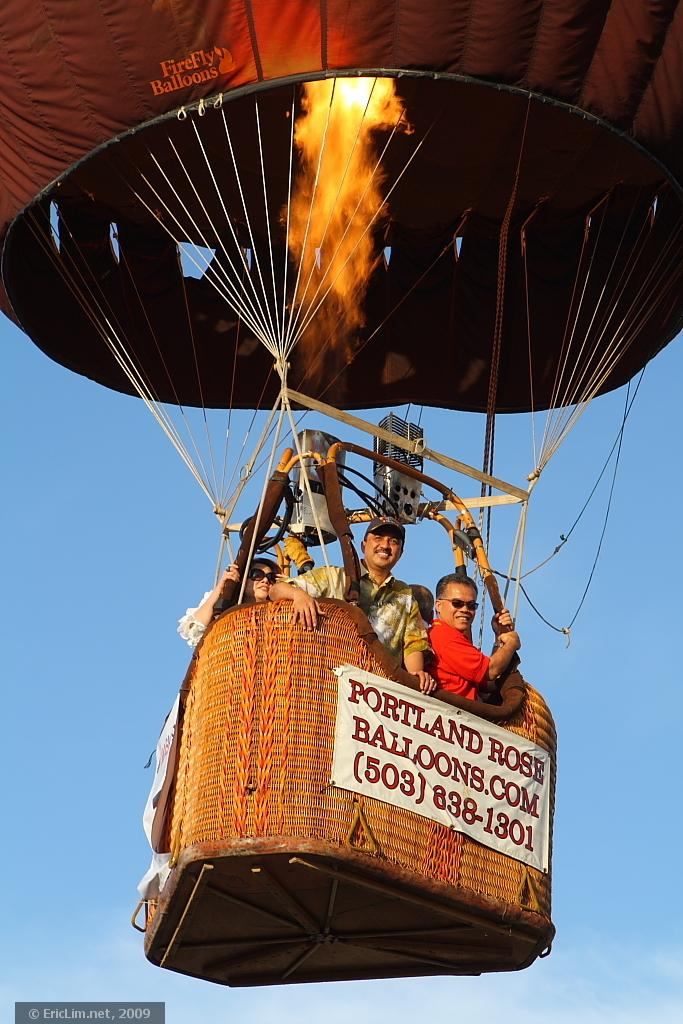<image>
Create a compact narrative representing the image presented. A group of people are riding in a hot air balloon that says Portland Rose Balloons. 